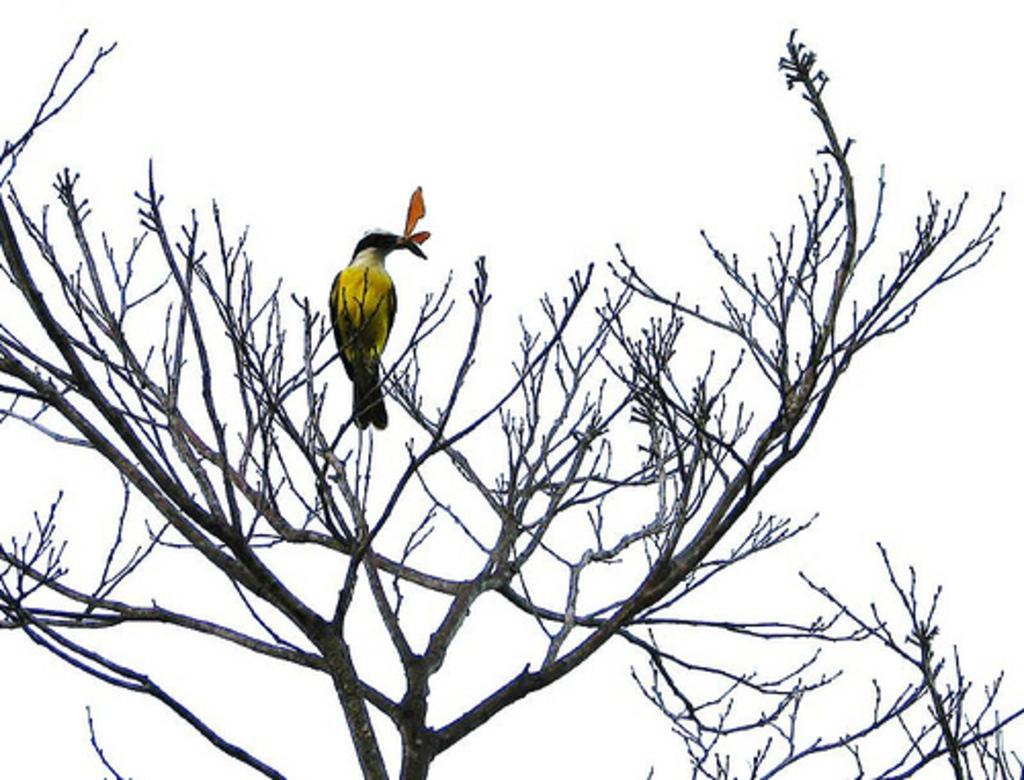What type of animal can be seen in the image? There is a bird in the image. Where is the bird located? The bird is on a tree. What is the bird doing with its beak? The bird is holding leaves with its beak. What else can be seen on the tree besides the bird? There are branches visible in the image. What is visible in the background of the image? The sky is visible in the background of the image. What type of trouble is the bird causing for its mom in the image? There is no indication of any trouble or mom in the image; it simply shows a bird holding leaves on a tree. 